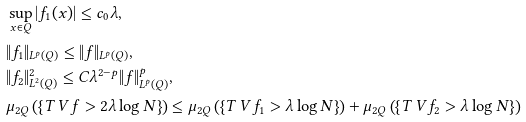Convert formula to latex. <formula><loc_0><loc_0><loc_500><loc_500>& \sup _ { x \in Q } | f _ { 1 } ( x ) | \leq c _ { 0 } \lambda , \\ & \| f _ { 1 } \| _ { L ^ { p } ( Q ) } \leq \| f \| _ { L ^ { p } ( Q ) } , \\ & \| f _ { 2 } \| _ { L ^ { 2 } ( Q ) } ^ { 2 } \leq C \lambda ^ { 2 - p } \| f \| _ { L ^ { p } ( Q ) } ^ { p } , \\ & \mu _ { 2 Q } \left ( \left \{ T _ { \ } V f > 2 \lambda \log N \right \} \right ) \leq \mu _ { 2 Q } \left ( \left \{ T _ { \ } V f _ { 1 } > \lambda \log N \right \} \right ) + \mu _ { 2 Q } \left ( \left \{ T _ { \ } V f _ { 2 } > \lambda \log N \right \} \right )</formula> 